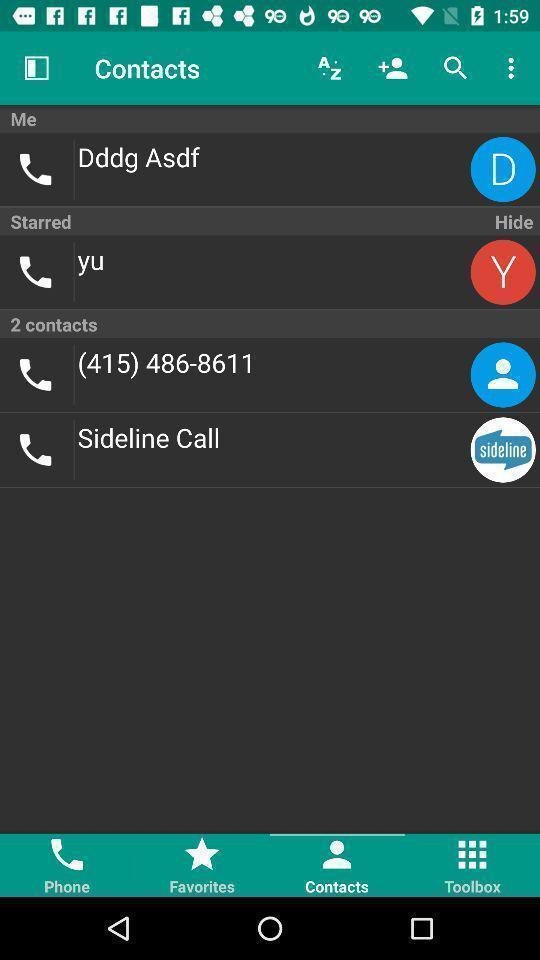Provide a detailed account of this screenshot. Screen shows multiple contact details in a call app. 